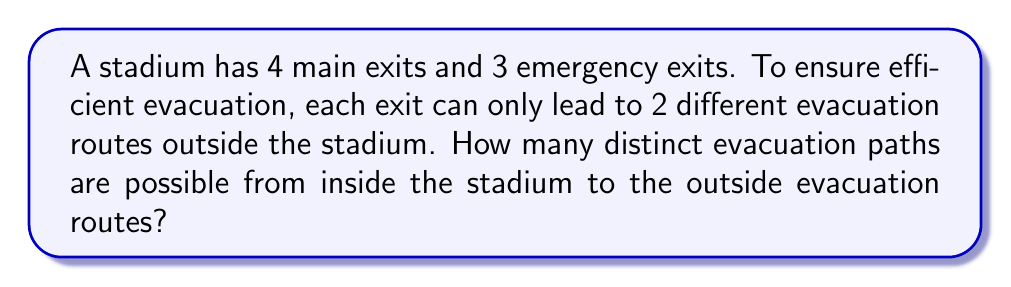Can you solve this math problem? Let's approach this step-by-step:

1) First, we need to calculate the total number of exits:
   $4$ main exits + $3$ emergency exits = $7$ total exits

2) Each exit leads to 2 different evacuation routes. This means we have two choices for each exit.

3) This scenario can be modeled as a multiplication principle problem. For each exit, we have 2 choices, and we need to make this choice for all 7 exits.

4) The multiplication principle states that if we have $n$ independent events, and each event $i$ has $m_i$ possible outcomes, then the total number of possible outcomes for all events is the product of the number of outcomes for each event.

5) In this case, we have 7 independent events (choosing a route for each exit), and each event has 2 possible outcomes.

6) Therefore, the total number of distinct evacuation paths is:

   $$ 2 \times 2 \times 2 \times 2 \times 2 \times 2 \times 2 = 2^7 $$

7) Calculate $2^7$:
   $$ 2^7 = 128 $$

Thus, there are 128 distinct evacuation paths possible.
Answer: 128 